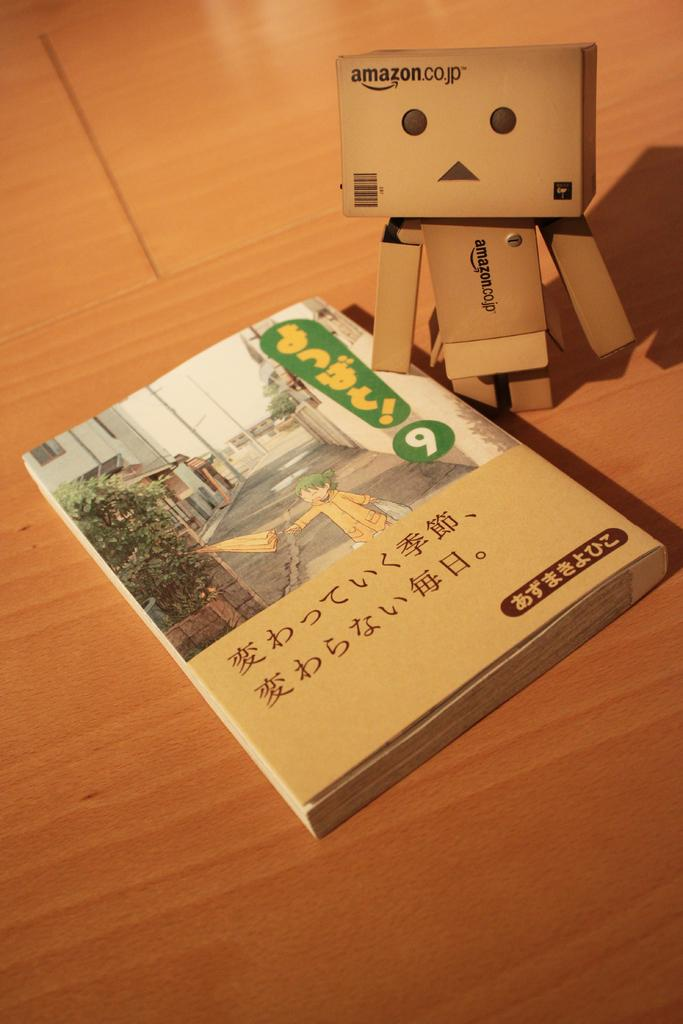<image>
Provide a brief description of the given image. Amazon.co.jp website on a brown box with a bar code. 